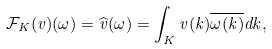Convert formula to latex. <formula><loc_0><loc_0><loc_500><loc_500>\mathcal { F } _ { K } ( v ) ( \omega ) = \widehat { v } ( \omega ) = \int _ { K } v ( k ) \overline { \omega ( k ) } d k ,</formula> 